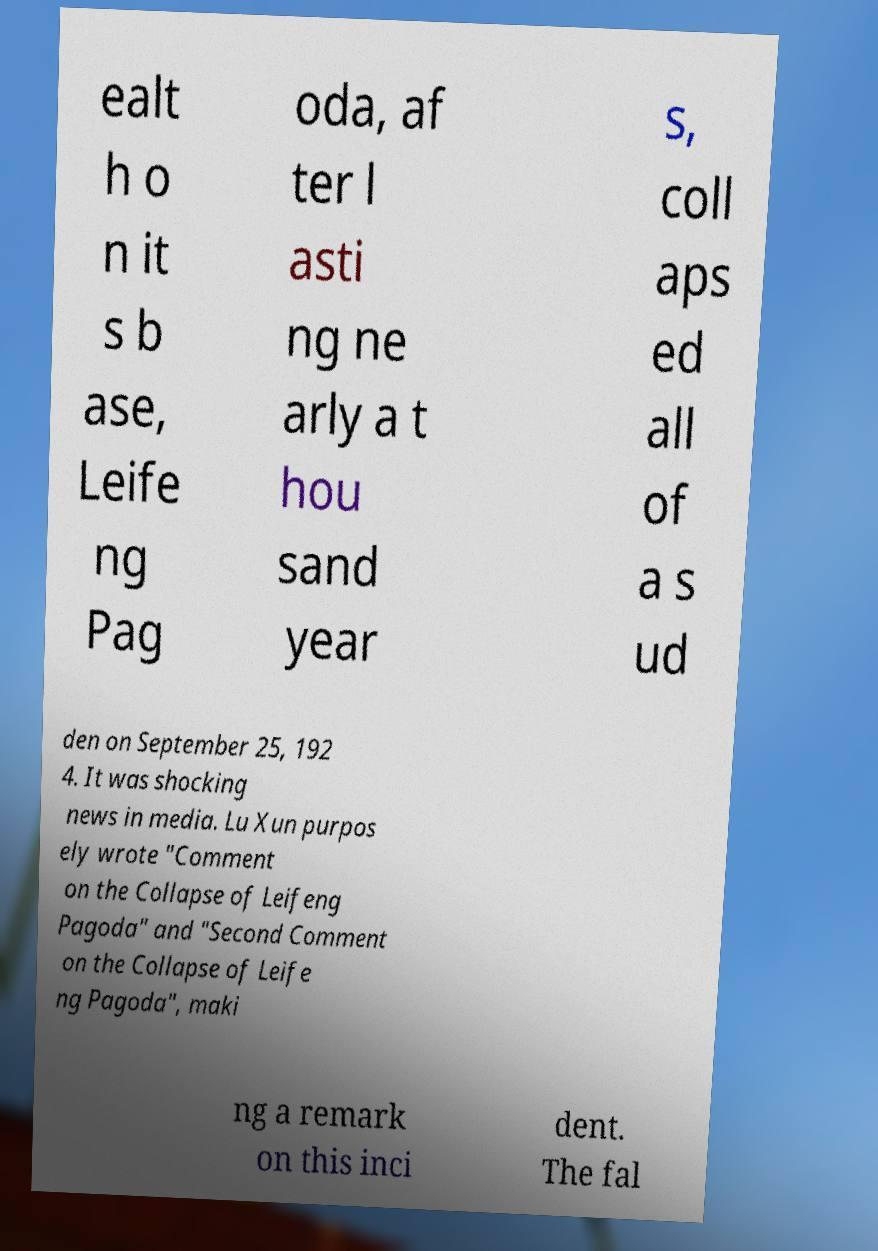Please identify and transcribe the text found in this image. ealt h o n it s b ase, Leife ng Pag oda, af ter l asti ng ne arly a t hou sand year s, coll aps ed all of a s ud den on September 25, 192 4. It was shocking news in media. Lu Xun purpos ely wrote "Comment on the Collapse of Leifeng Pagoda" and "Second Comment on the Collapse of Leife ng Pagoda", maki ng a remark on this inci dent. The fal 